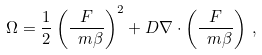<formula> <loc_0><loc_0><loc_500><loc_500>\Omega = \frac { 1 } { 2 } \left ( \frac { F } { \ m \beta } \right ) ^ { 2 } + D { \nabla } \cdot \left ( \frac { F } { \ m \beta } \right ) \, ,</formula> 